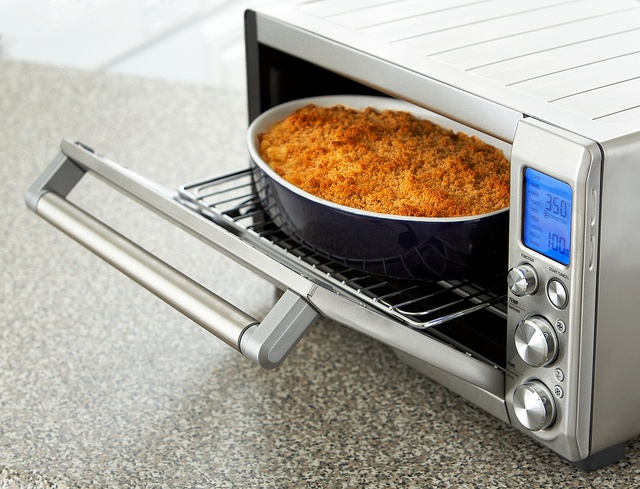Describe the objects in this image and their specific colors. I can see microwave in white, darkgray, black, and gray tones, bowl in white, black, brown, red, and orange tones, cake in white, brown, red, orange, and maroon tones, and oven in white, black, gray, and darkgray tones in this image. 